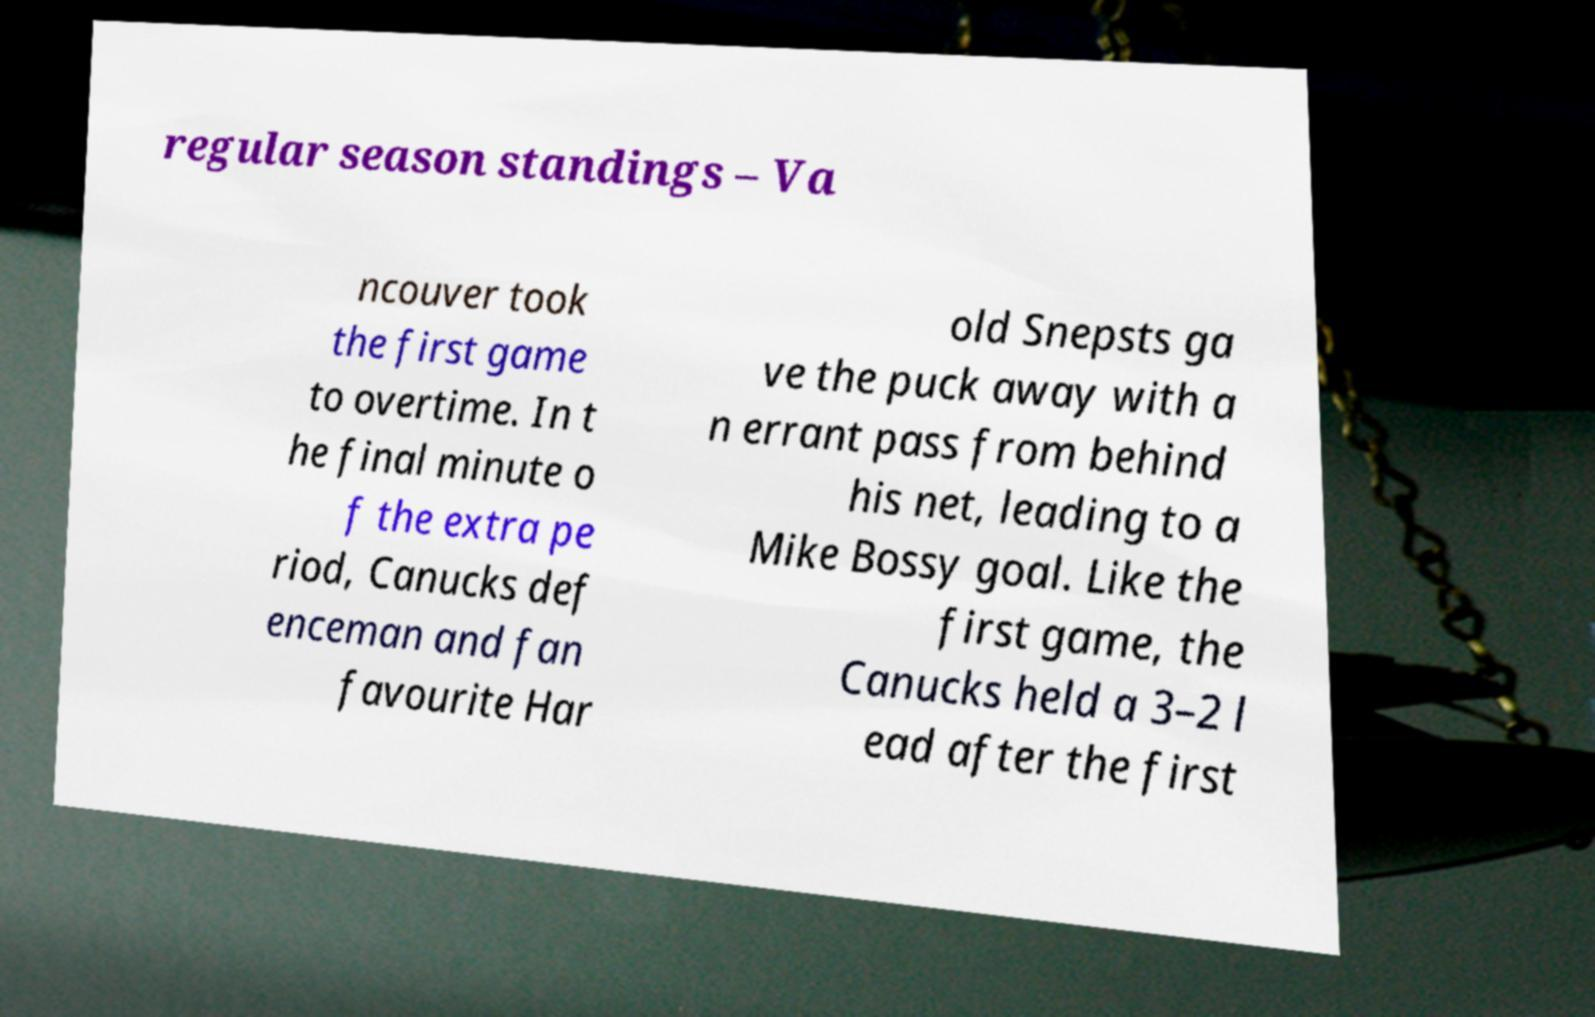Please read and relay the text visible in this image. What does it say? regular season standings – Va ncouver took the first game to overtime. In t he final minute o f the extra pe riod, Canucks def enceman and fan favourite Har old Snepsts ga ve the puck away with a n errant pass from behind his net, leading to a Mike Bossy goal. Like the first game, the Canucks held a 3–2 l ead after the first 